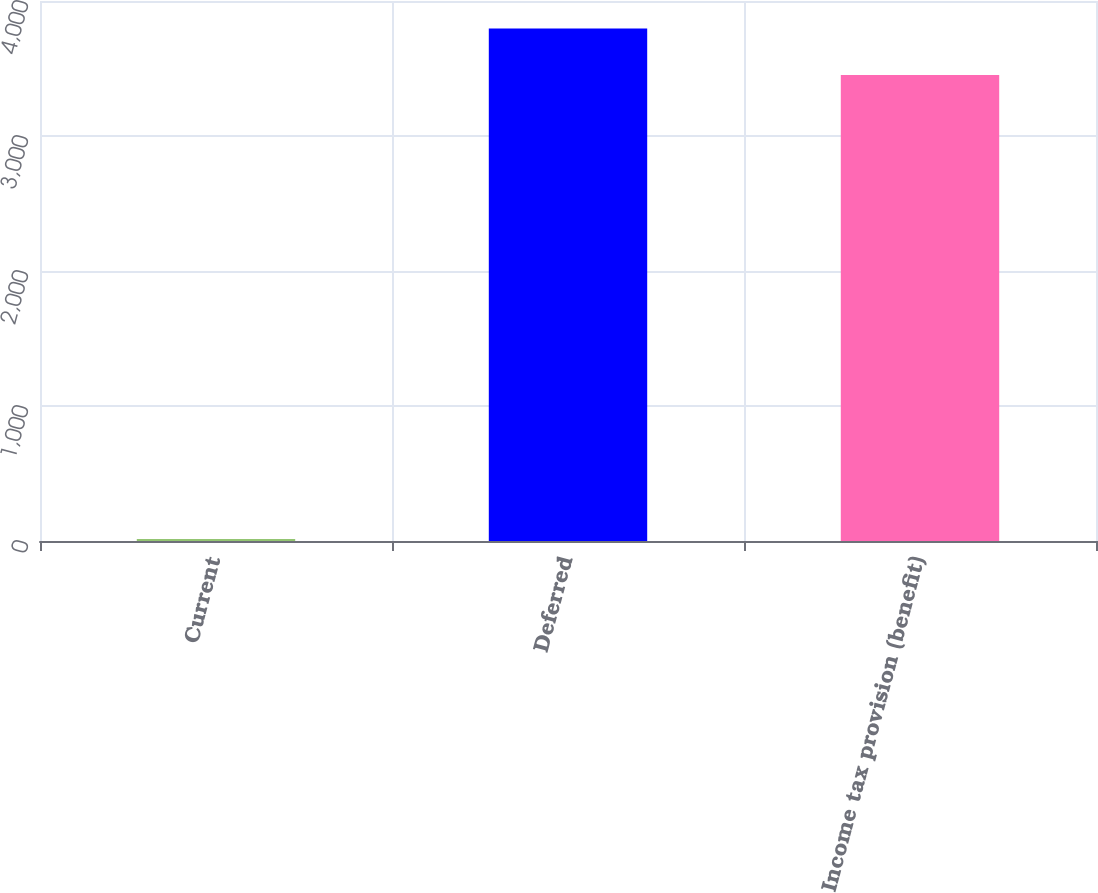<chart> <loc_0><loc_0><loc_500><loc_500><bar_chart><fcel>Current<fcel>Deferred<fcel>Income tax provision (benefit)<nl><fcel>15<fcel>3797.2<fcel>3452<nl></chart> 